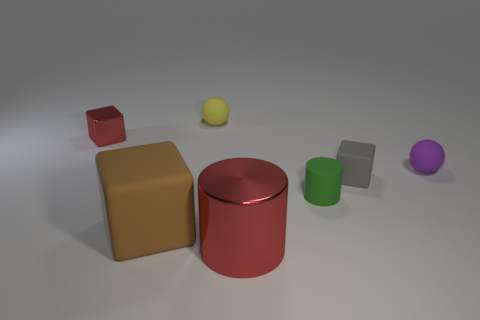Subtract all small cubes. How many cubes are left? 1 Subtract all red cubes. How many cubes are left? 2 Add 1 red cylinders. How many objects exist? 8 Subtract all cylinders. How many objects are left? 5 Subtract 2 balls. How many balls are left? 0 Add 6 red metal spheres. How many red metal spheres exist? 6 Subtract 1 green cylinders. How many objects are left? 6 Subtract all green blocks. Subtract all red spheres. How many blocks are left? 3 Subtract all gray blocks. Subtract all big red metallic cylinders. How many objects are left? 5 Add 5 brown matte cubes. How many brown matte cubes are left? 6 